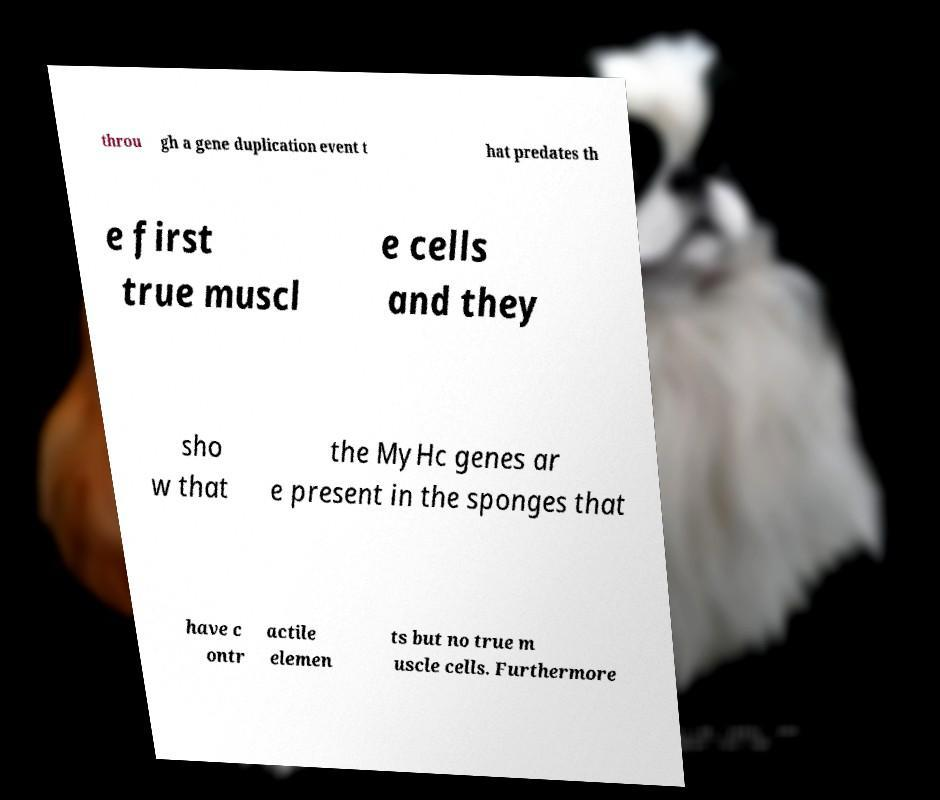Please identify and transcribe the text found in this image. throu gh a gene duplication event t hat predates th e first true muscl e cells and they sho w that the MyHc genes ar e present in the sponges that have c ontr actile elemen ts but no true m uscle cells. Furthermore 